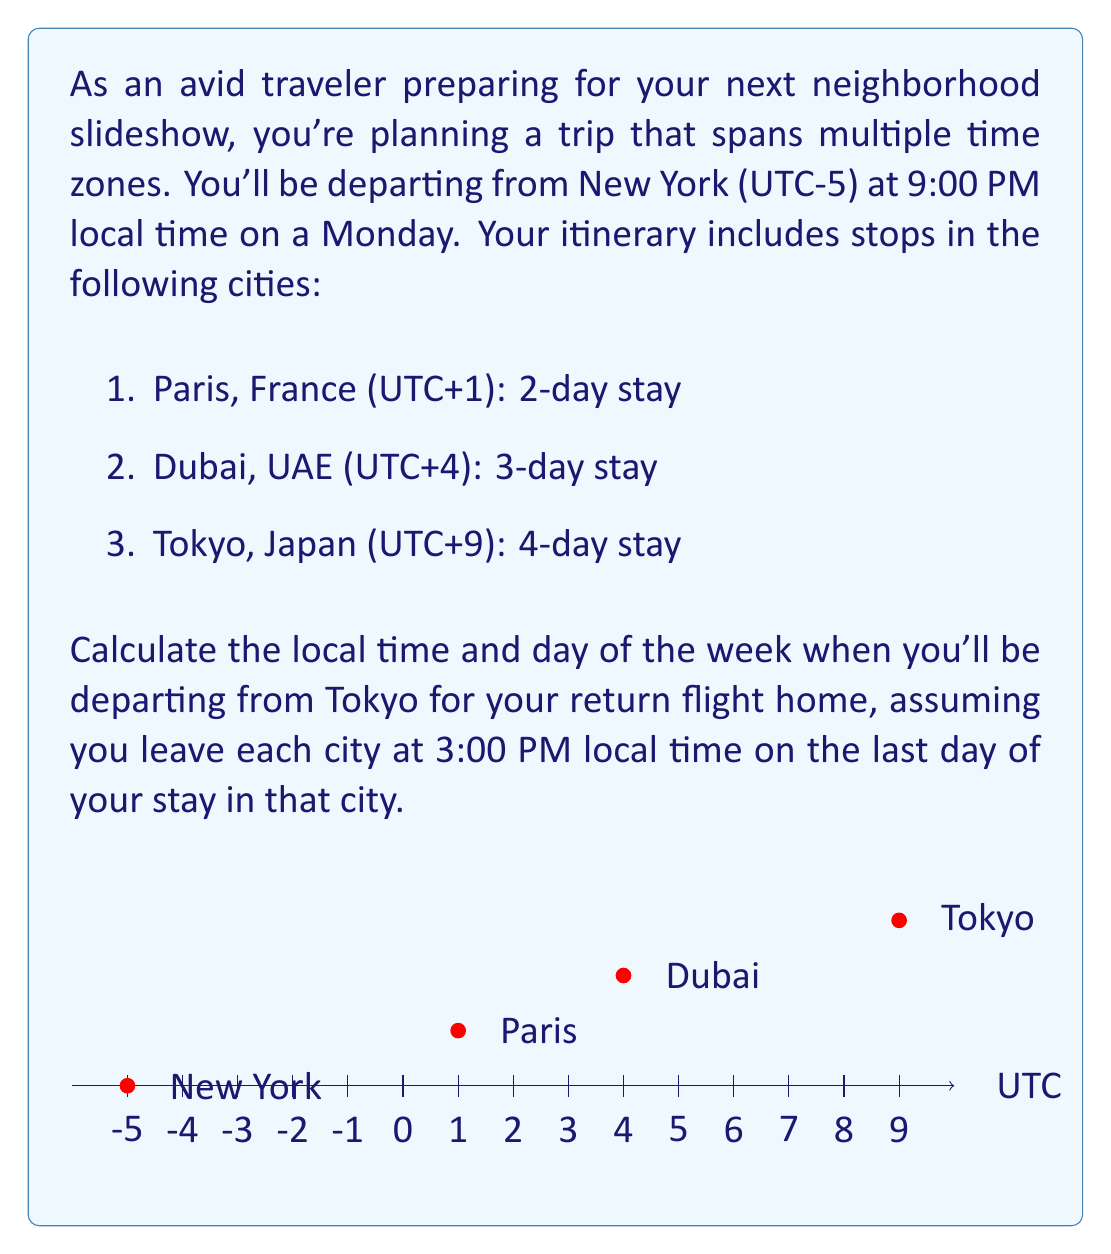Provide a solution to this math problem. Let's solve this problem step by step:

1) First, let's calculate the total travel time:
   - New York to Paris: $24 + 6 = 30$ hours (1 day and 6 hours)
   - Stay in Paris: 2 days
   - Paris to Dubai: 3 hours
   - Stay in Dubai: 3 days
   - Dubai to Tokyo: 5 hours
   - Stay in Tokyo: 4 days

2) Total time from departure in New York to departure from Tokyo:
   $$(30 + 48 + 3 + 72 + 5 + 96) = 254$$ hours

3) Convert 254 hours to days and hours:
   $254 \div 24 = 10$ days and $14$ hours

4) Starting from Monday 9:00 PM in New York:
   - 10 days later is Thursday
   - 14 hours later is 11:00 AM
   - Add 4 more hours to reach 3:00 PM departure time in Tokyo

5) Time zone difference between New York and Tokyo:
   $UTC+9 - (UTC-5) = 14$ hours

6) Adjust for time zone difference:
   11:00 AM New York time + 14 hours = 1:00 AM next day in Tokyo

Therefore, when it's 3:00 PM on Thursday in Tokyo, it's 1:00 AM on Friday in New York.
Answer: 3:00 PM on Friday 